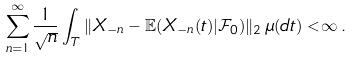<formula> <loc_0><loc_0><loc_500><loc_500>\sum _ { n = 1 } ^ { \infty } \frac { 1 } { \sqrt { n } } \int _ { T } \| X _ { - n } - \mathbb { E } ( X _ { - n } ( t ) | \mathcal { F } _ { 0 } ) \| _ { 2 } \, \mu ( d t ) < \infty \, .</formula> 